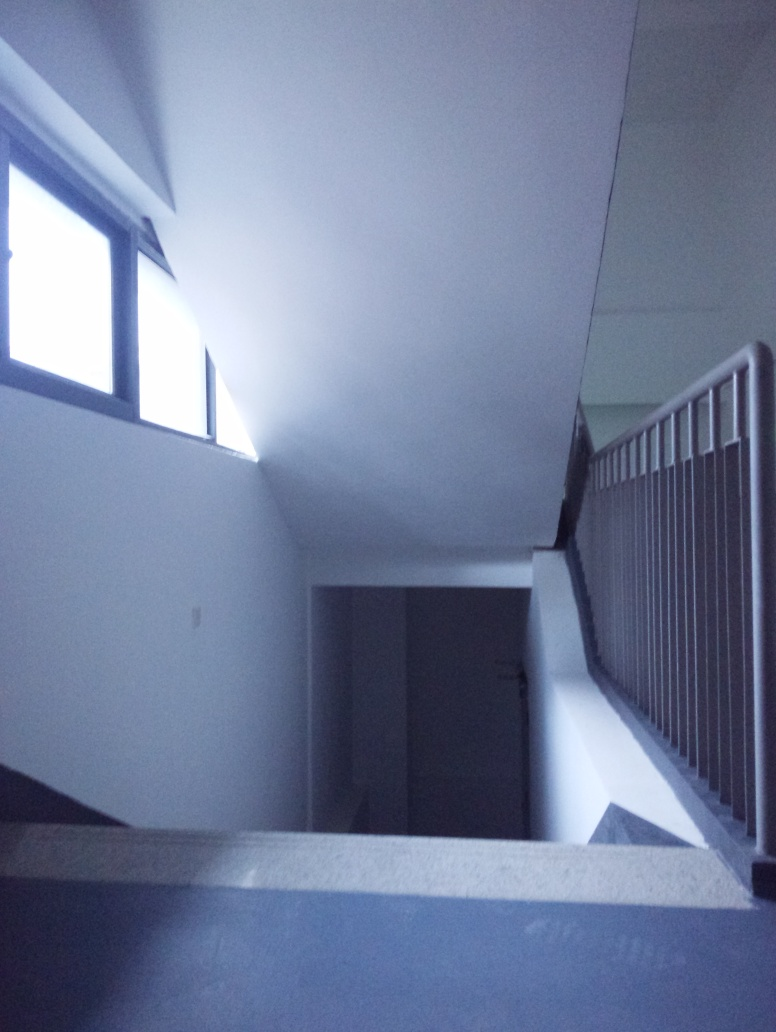Can you describe the mood or atmosphere conveyed by this image? The image conveys a tranquil yet somewhat somber mood. The cool tones and the shadowy staircase suggest a quiet, perhaps lonely atmosphere. The simplicity and minimalism in the scene might evoke a sense of introspection or calmness. 